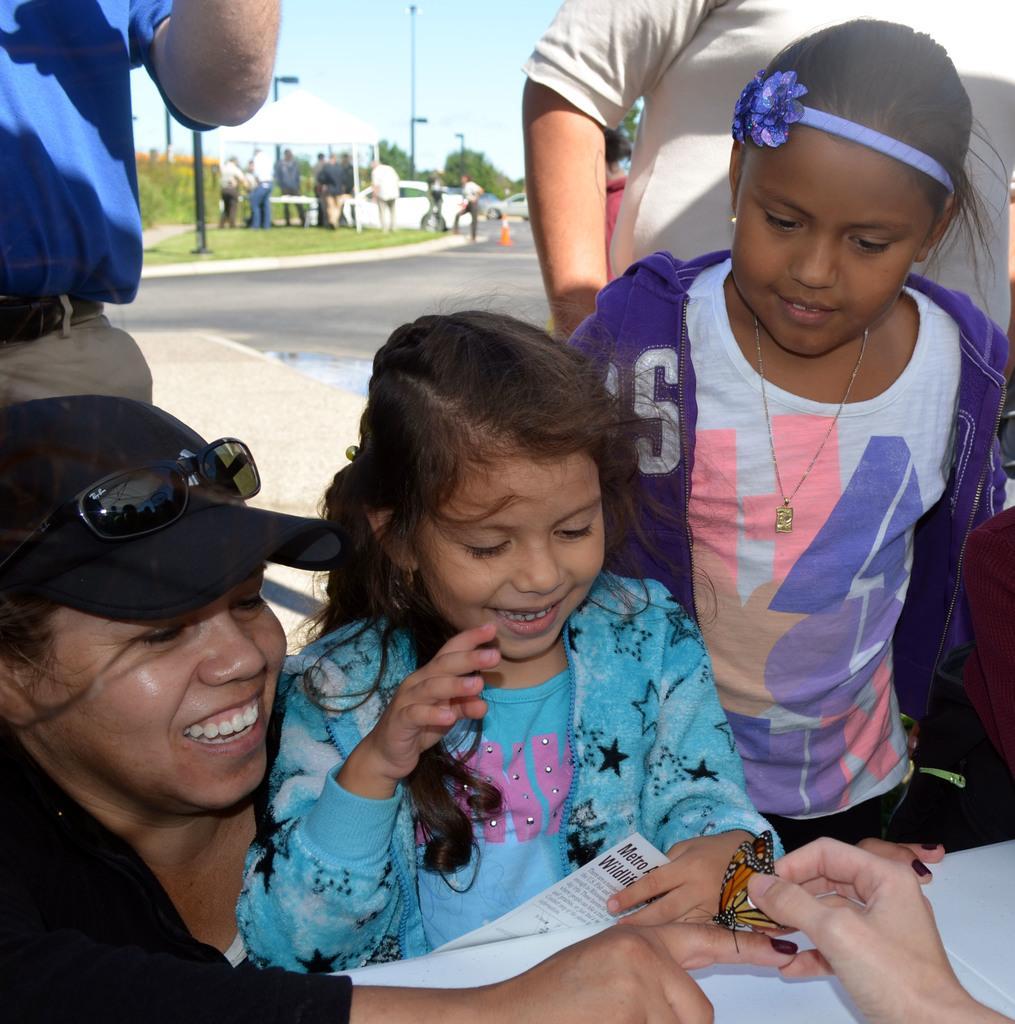In one or two sentences, can you explain what this image depicts? In this image I can see group of people. There are fingers of a person holding butterfly. In the background there are other group of people standing, there are trees, poles , vehicles and there is sky. 